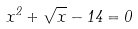Convert formula to latex. <formula><loc_0><loc_0><loc_500><loc_500>x ^ { 2 } + \sqrt { x } - 1 4 = 0</formula> 